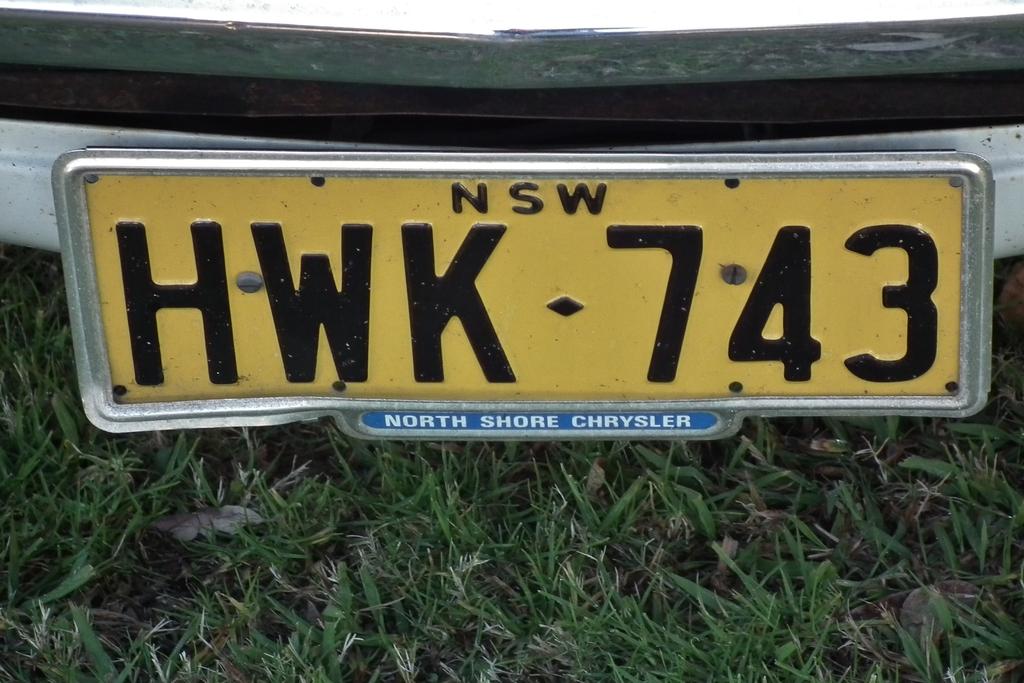What business was the seller of this car?
Ensure brevity in your answer.  North shore chrysler. What is the license plate?
Your answer should be compact. Hwk 743. 